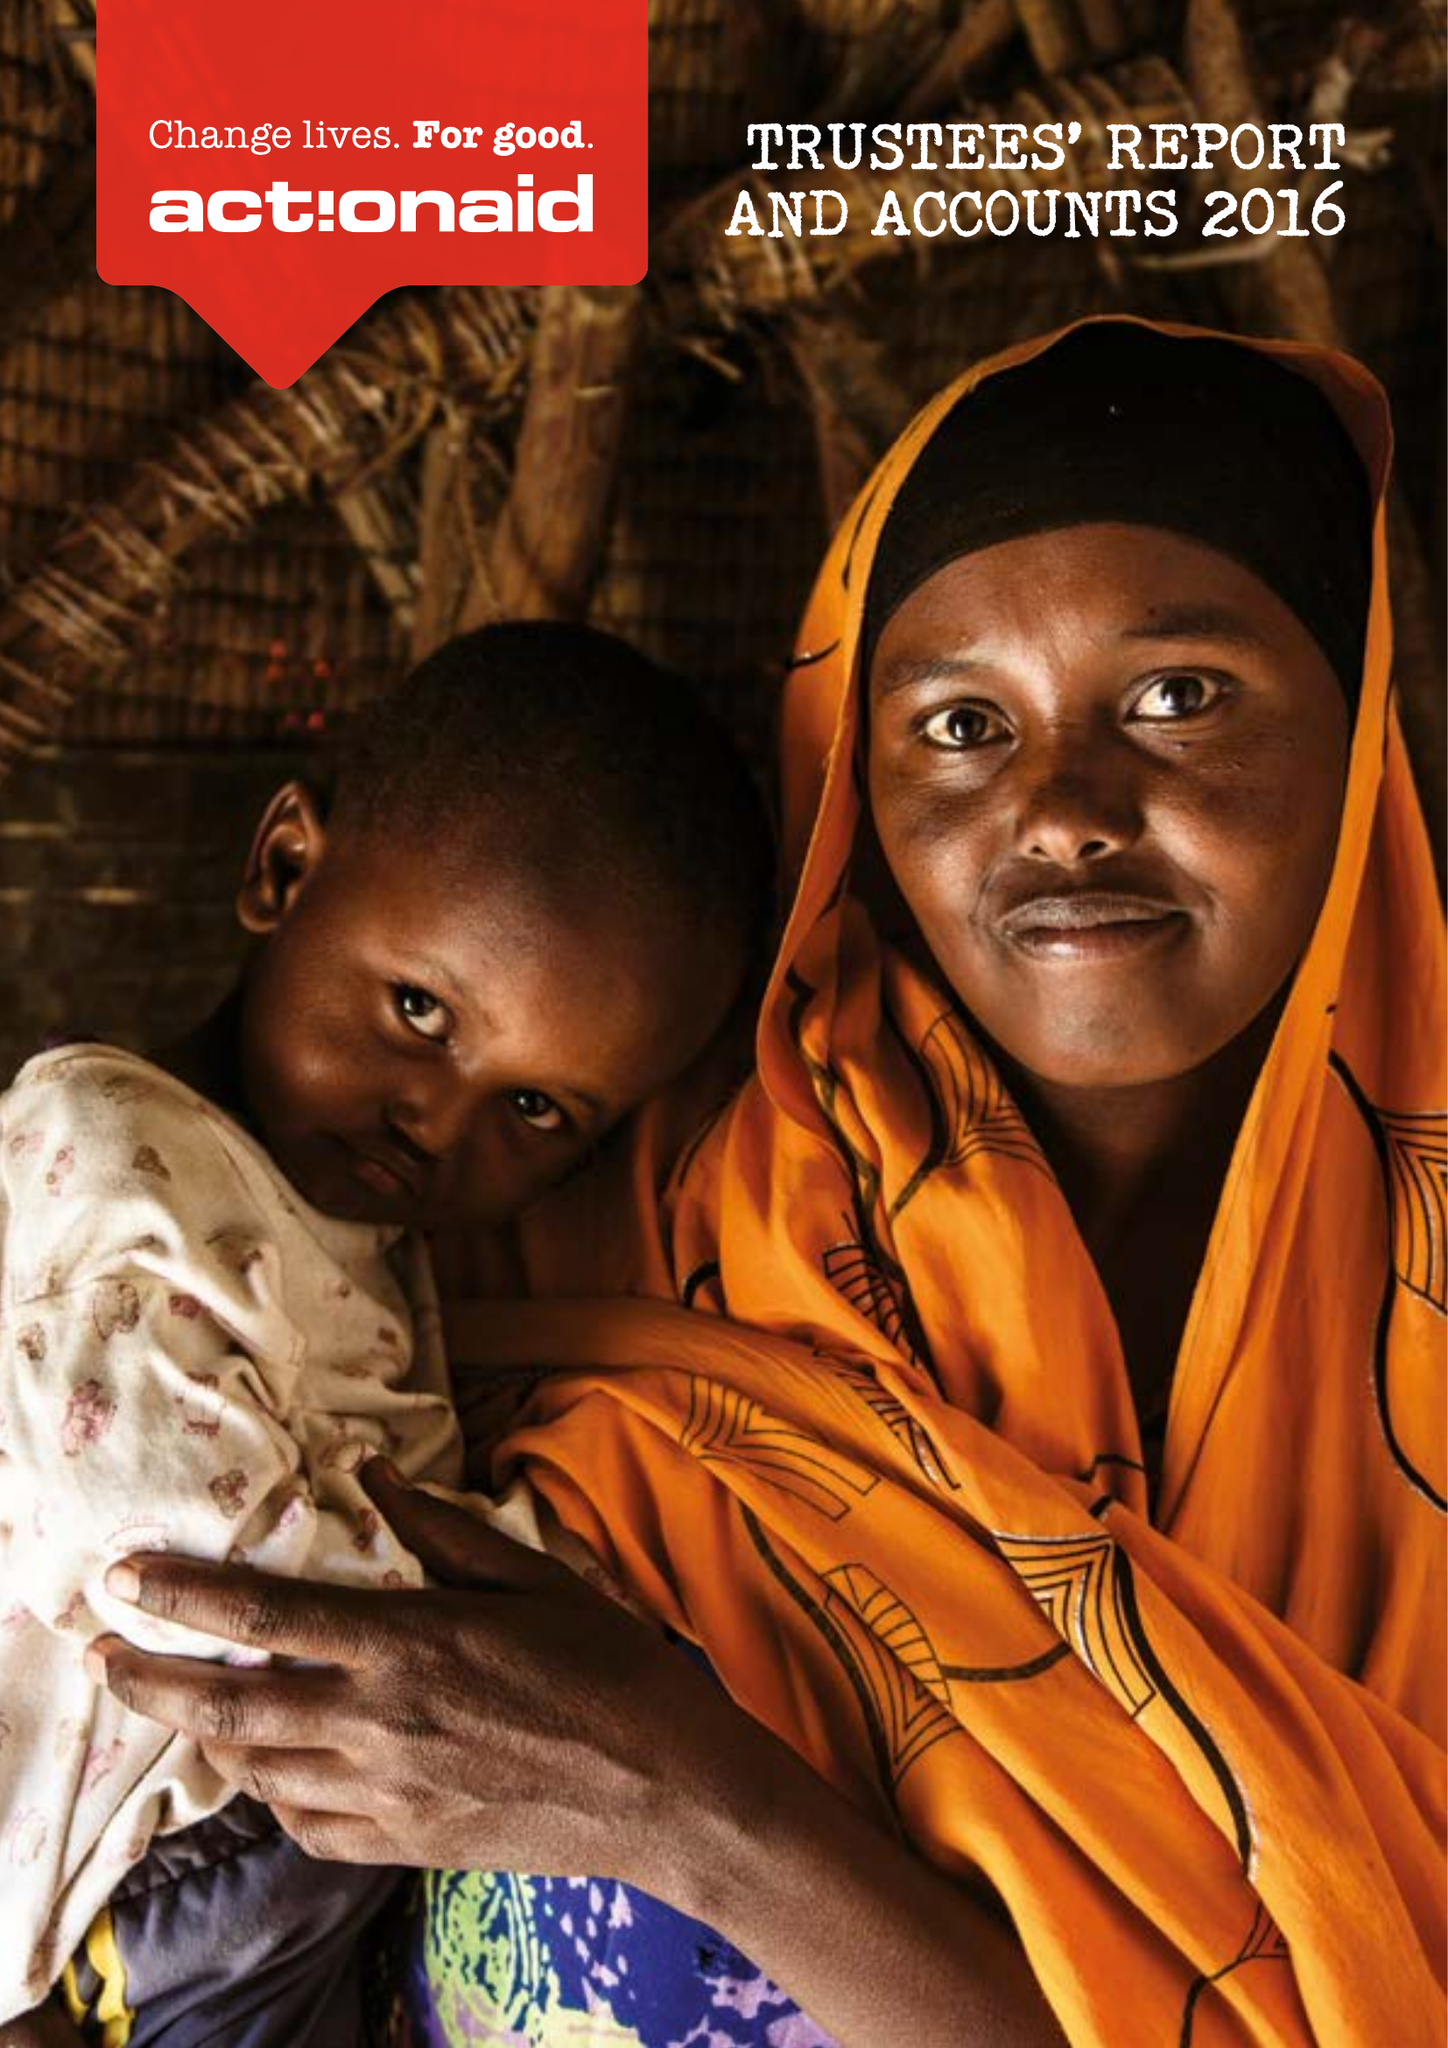What is the value for the income_annually_in_british_pounds?
Answer the question using a single word or phrase. 60406000.00 